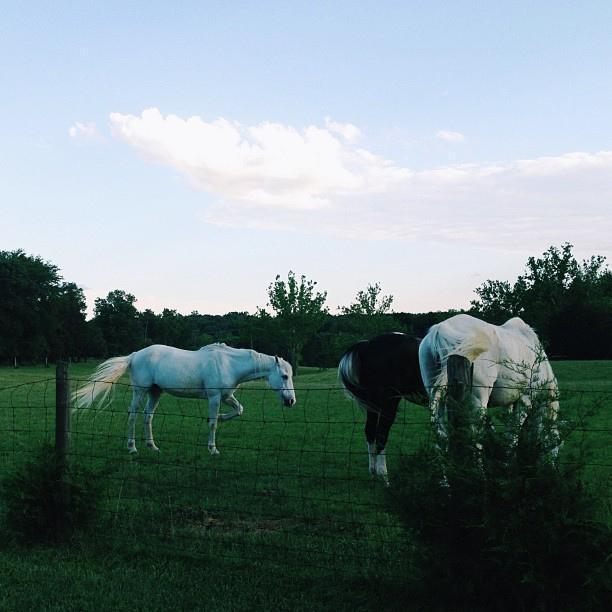How many horses have their hind parts facing the camera?
Give a very brief answer. 2. How many horses are there?
Give a very brief answer. 3. 